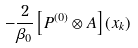<formula> <loc_0><loc_0><loc_500><loc_500>- \frac { 2 } { \beta _ { 0 } } \left [ P ^ { ( 0 ) } \otimes A \right ] ( x _ { k } )</formula> 